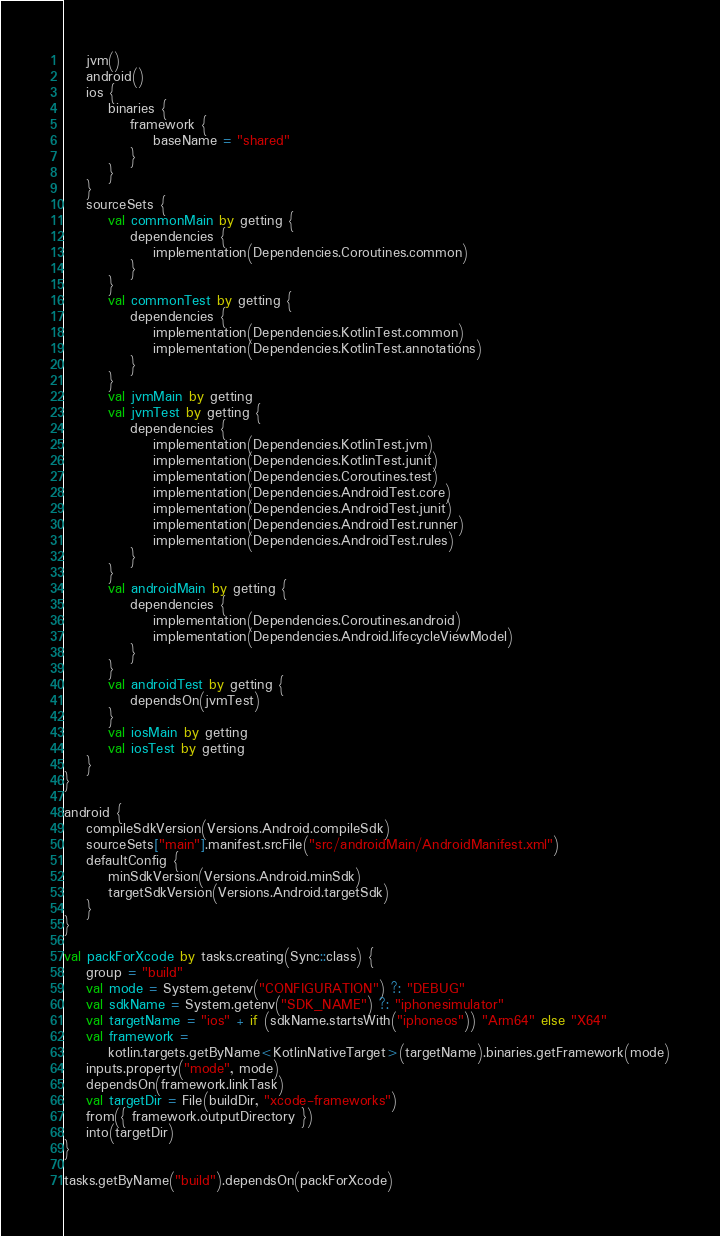<code> <loc_0><loc_0><loc_500><loc_500><_Kotlin_>    jvm()
    android()
    ios {
        binaries {
            framework {
                baseName = "shared"
            }
        }
    }
    sourceSets {
        val commonMain by getting {
            dependencies {
                implementation(Dependencies.Coroutines.common)
            }
        }
        val commonTest by getting {
            dependencies {
                implementation(Dependencies.KotlinTest.common)
                implementation(Dependencies.KotlinTest.annotations)
            }
        }
        val jvmMain by getting
        val jvmTest by getting {
            dependencies {
                implementation(Dependencies.KotlinTest.jvm)
                implementation(Dependencies.KotlinTest.junit)
                implementation(Dependencies.Coroutines.test)
                implementation(Dependencies.AndroidTest.core)
                implementation(Dependencies.AndroidTest.junit)
                implementation(Dependencies.AndroidTest.runner)
                implementation(Dependencies.AndroidTest.rules)
            }
        }
        val androidMain by getting {
            dependencies {
                implementation(Dependencies.Coroutines.android)
                implementation(Dependencies.Android.lifecycleViewModel)
            }
        }
        val androidTest by getting {
            dependsOn(jvmTest)
        }
        val iosMain by getting
        val iosTest by getting
    }
}

android {
    compileSdkVersion(Versions.Android.compileSdk)
    sourceSets["main"].manifest.srcFile("src/androidMain/AndroidManifest.xml")
    defaultConfig {
        minSdkVersion(Versions.Android.minSdk)
        targetSdkVersion(Versions.Android.targetSdk)
    }
}

val packForXcode by tasks.creating(Sync::class) {
    group = "build"
    val mode = System.getenv("CONFIGURATION") ?: "DEBUG"
    val sdkName = System.getenv("SDK_NAME") ?: "iphonesimulator"
    val targetName = "ios" + if (sdkName.startsWith("iphoneos")) "Arm64" else "X64"
    val framework =
        kotlin.targets.getByName<KotlinNativeTarget>(targetName).binaries.getFramework(mode)
    inputs.property("mode", mode)
    dependsOn(framework.linkTask)
    val targetDir = File(buildDir, "xcode-frameworks")
    from({ framework.outputDirectory })
    into(targetDir)
}

tasks.getByName("build").dependsOn(packForXcode)</code> 